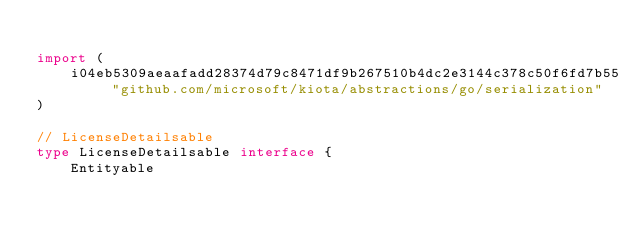Convert code to text. <code><loc_0><loc_0><loc_500><loc_500><_Go_>
import (
    i04eb5309aeaafadd28374d79c8471df9b267510b4dc2e3144c378c50f6fd7b55 "github.com/microsoft/kiota/abstractions/go/serialization"
)

// LicenseDetailsable 
type LicenseDetailsable interface {
    Entityable</code> 